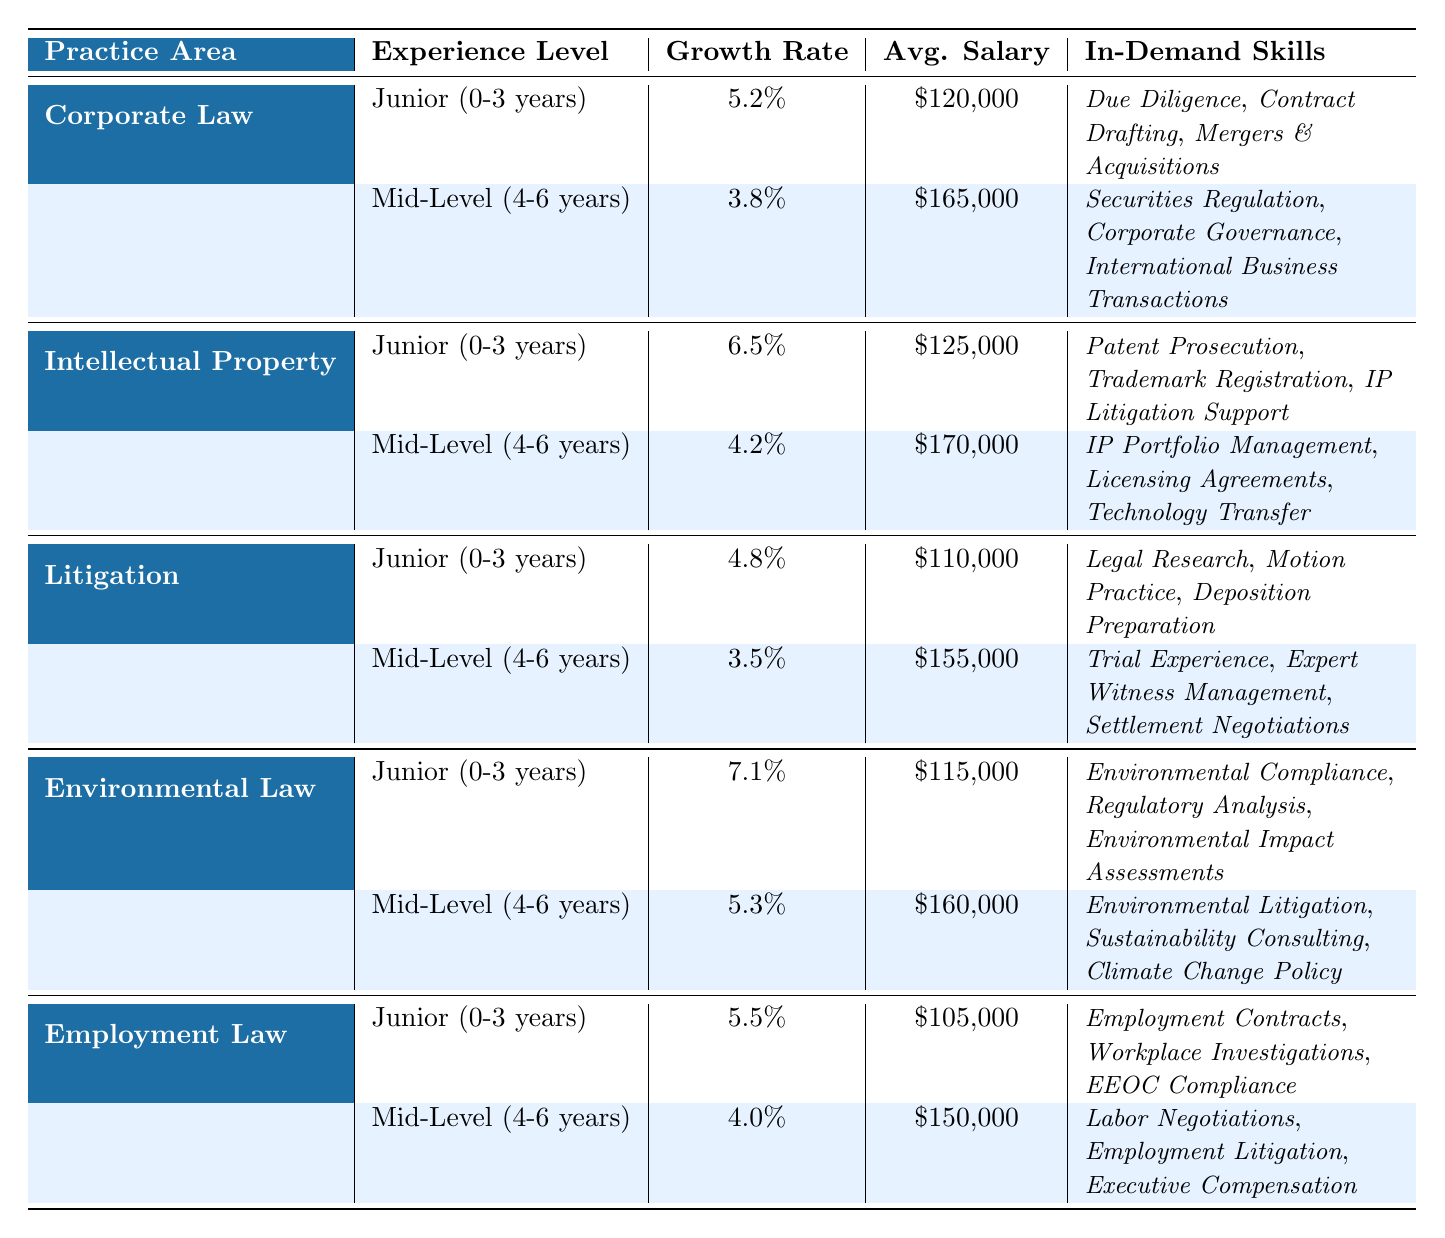What is the average salary for a Junior attorney in Environmental Law? The average salary for a Junior attorney in Environmental Law is listed as $115,000.
Answer: $115,000 What in-demand skill is associated with Mid-Level attorneys in Corporate Law? The table shows that in-demand skills for Mid-Level attorneys in Corporate Law include Securities Regulation, Corporate Governance, and International Business Transactions. One of them is Securities Regulation.
Answer: Securities Regulation Which practice area has the highest growth rate for Junior attorneys? By comparing the growth rates for Junior attorneys across all practice areas, Environmental Law has the highest growth rate at 7.1%.
Answer: 7.1% What is the salary difference between Mid-Level attorneys in Employment Law and Litigation? The average salary for Mid-Level attorneys in Employment Law is $150,000, and in Litigation, it is $155,000. The difference is $155,000 - $150,000 = $5,000.
Answer: $5,000 Is the growth rate for Junior attorneys higher in Intellectual Property than in Corporate Law? The growth rate for Junior attorneys in Intellectual Property is 6.5%, while in Corporate Law it is 5.2%. Since 6.5% is greater than 5.2%, the statement is true.
Answer: Yes What are the in-demand skills for Mid-Level attorneys in Environmental Law? The table lists the in-demand skills for Mid-Level attorneys in Environmental Law as Environmental Litigation, Sustainability Consulting, and Climate Change Policy.
Answer: Environmental Litigation, Sustainability Consulting, Climate Change Policy What is the average salary for a Mid-Level attorney in Intellectual Property compared to Corporate Law? The average salary for a Mid-Level attorney in Intellectual Property is $170,000, while in Corporate Law it is $165,000. The average salary for Intellectual Property is higher by $170,000 - $165,000 = $5,000.
Answer: $5,000 Which practice area has the lowest growth rate for Junior attorneys? The growth rates for Junior attorneys are 5.2% (Corporate Law), 6.5% (Intellectual Property), 4.8% (Litigation), 7.1% (Environmental Law), and 5.5% (Employment Law). The lowest growth rate is 4.8% in Litigation.
Answer: 4.8% What is the average salary for Junior attorneys across all practice areas? The salaries for Junior attorneys are $120,000 (Corporate Law), $125,000 (Intellectual Property), $110,000 (Litigation), $115,000 (Environmental Law), and $105,000 (Employment Law). The average salary is calculated as: (120,000 + 125,000 + 110,000 + 115,000 + 105,000) / 5 = $115,000.
Answer: $115,000 Are the in-demand skills for Mid-Level attorneys in Corporate Law different from those in Employment Law? The in-demand skills for Mid-Level attorneys in Corporate Law include Securities Regulation and Corporate Governance, while in Employment Law, they include Labor Negotiations and Employment Litigation. Since the skills are not the same, the answer is true.
Answer: Yes 